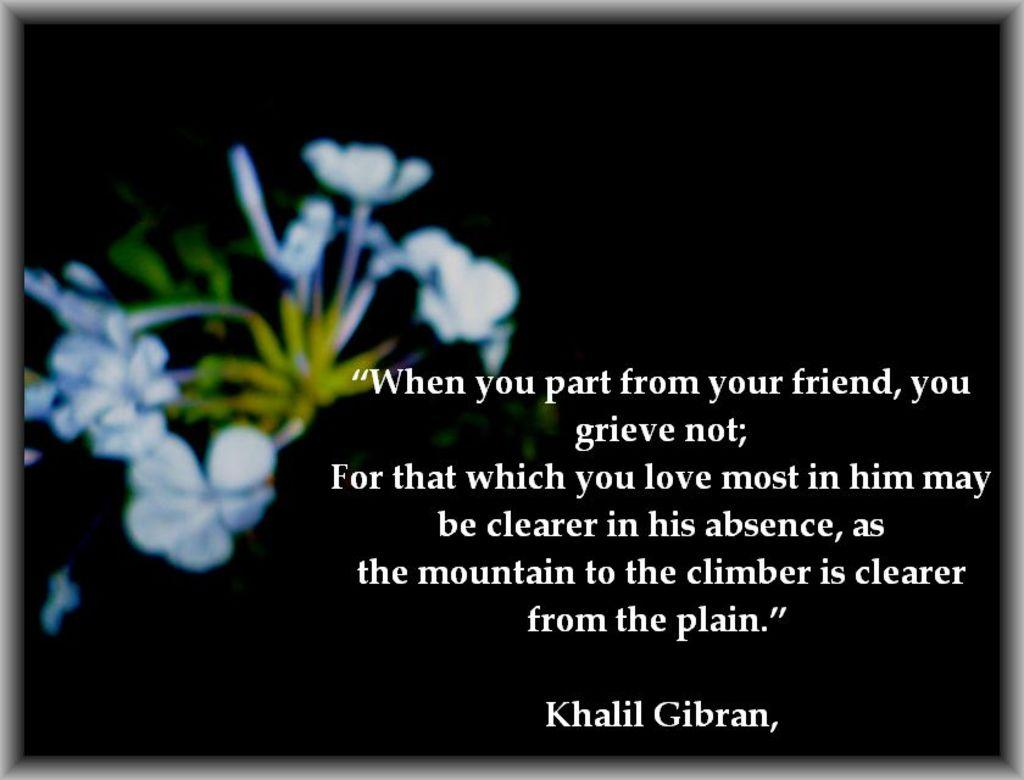What can be found in the image that contains written information? There is text in the image. How would you describe the overall appearance of the image? The background of the image is dark. What type of natural elements are present in the image? There are flowers in the image. How would you describe the appearance of the flowers in the image? The flowers are slightly blurred. What type of amusement can be seen in the image? There is no amusement present in the image; it features text, a dark background, and flowers. How does the thumb contribute to the image? There is no thumb present in the image. 